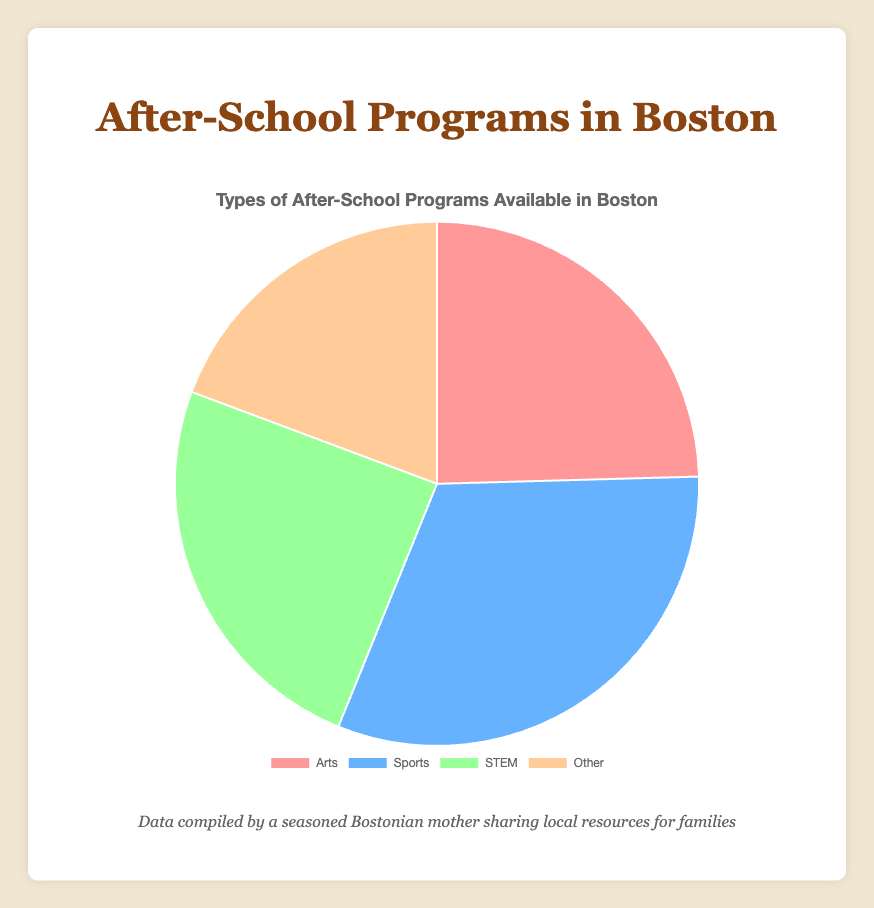What is the largest category of after-school programs? The largest category is determined by comparing the sizes of the segments in the pie chart. Sports has the largest segment.
Answer: Sports What is the smallest category of after-school programs? The smallest category is determined by comparing the sizes of the segments in the pie chart. "Other" has the smallest segment.
Answer: Other Which categories of after-school programs have an equal number of programs? From the pie chart, the segments for Arts and STEM appear equal. Each category has 70 programs.
Answer: Arts and STEM What is the total number of after-school programs represented in the chart? To find the total, sum the numbers of each category: 70 (Arts) + 90 (Sports) + 70 (STEM) + 55 (Other) = 285
Answer: 285 Which category has more programs, Arts or Sports? By comparing the segments, Sports has 90 programs which is more than the 70 programs in Arts.
Answer: Sports By how much does the number of Sports programs exceed the number of STEM programs? To find the difference, subtract the number of STEM programs from the number of Sports programs: 90 (Sports) - 70 (STEM) = 20
Answer: 20 What is the average number of programs per category? The average is obtained by dividing the total number of programs by the number of categories: 285 total programs / 4 categories = 71.25
Answer: 71.25 Which category is represented by the green color in the pie chart? By looking at the chart, the green segment represents the STEM category.
Answer: STEM Which has fewer programs, Arts or Other? By comparing the segments, Other has 55 programs which is fewer than the 70 programs in Arts.
Answer: Other Between STEM and Other, which category has more programs and by how many? STEM has 70 programs while Other has 55 programs. The difference is 70 (STEM) - 55 (Other) = 15
Answer: STEM by 15 